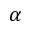Convert formula to latex. <formula><loc_0><loc_0><loc_500><loc_500>\alpha</formula> 